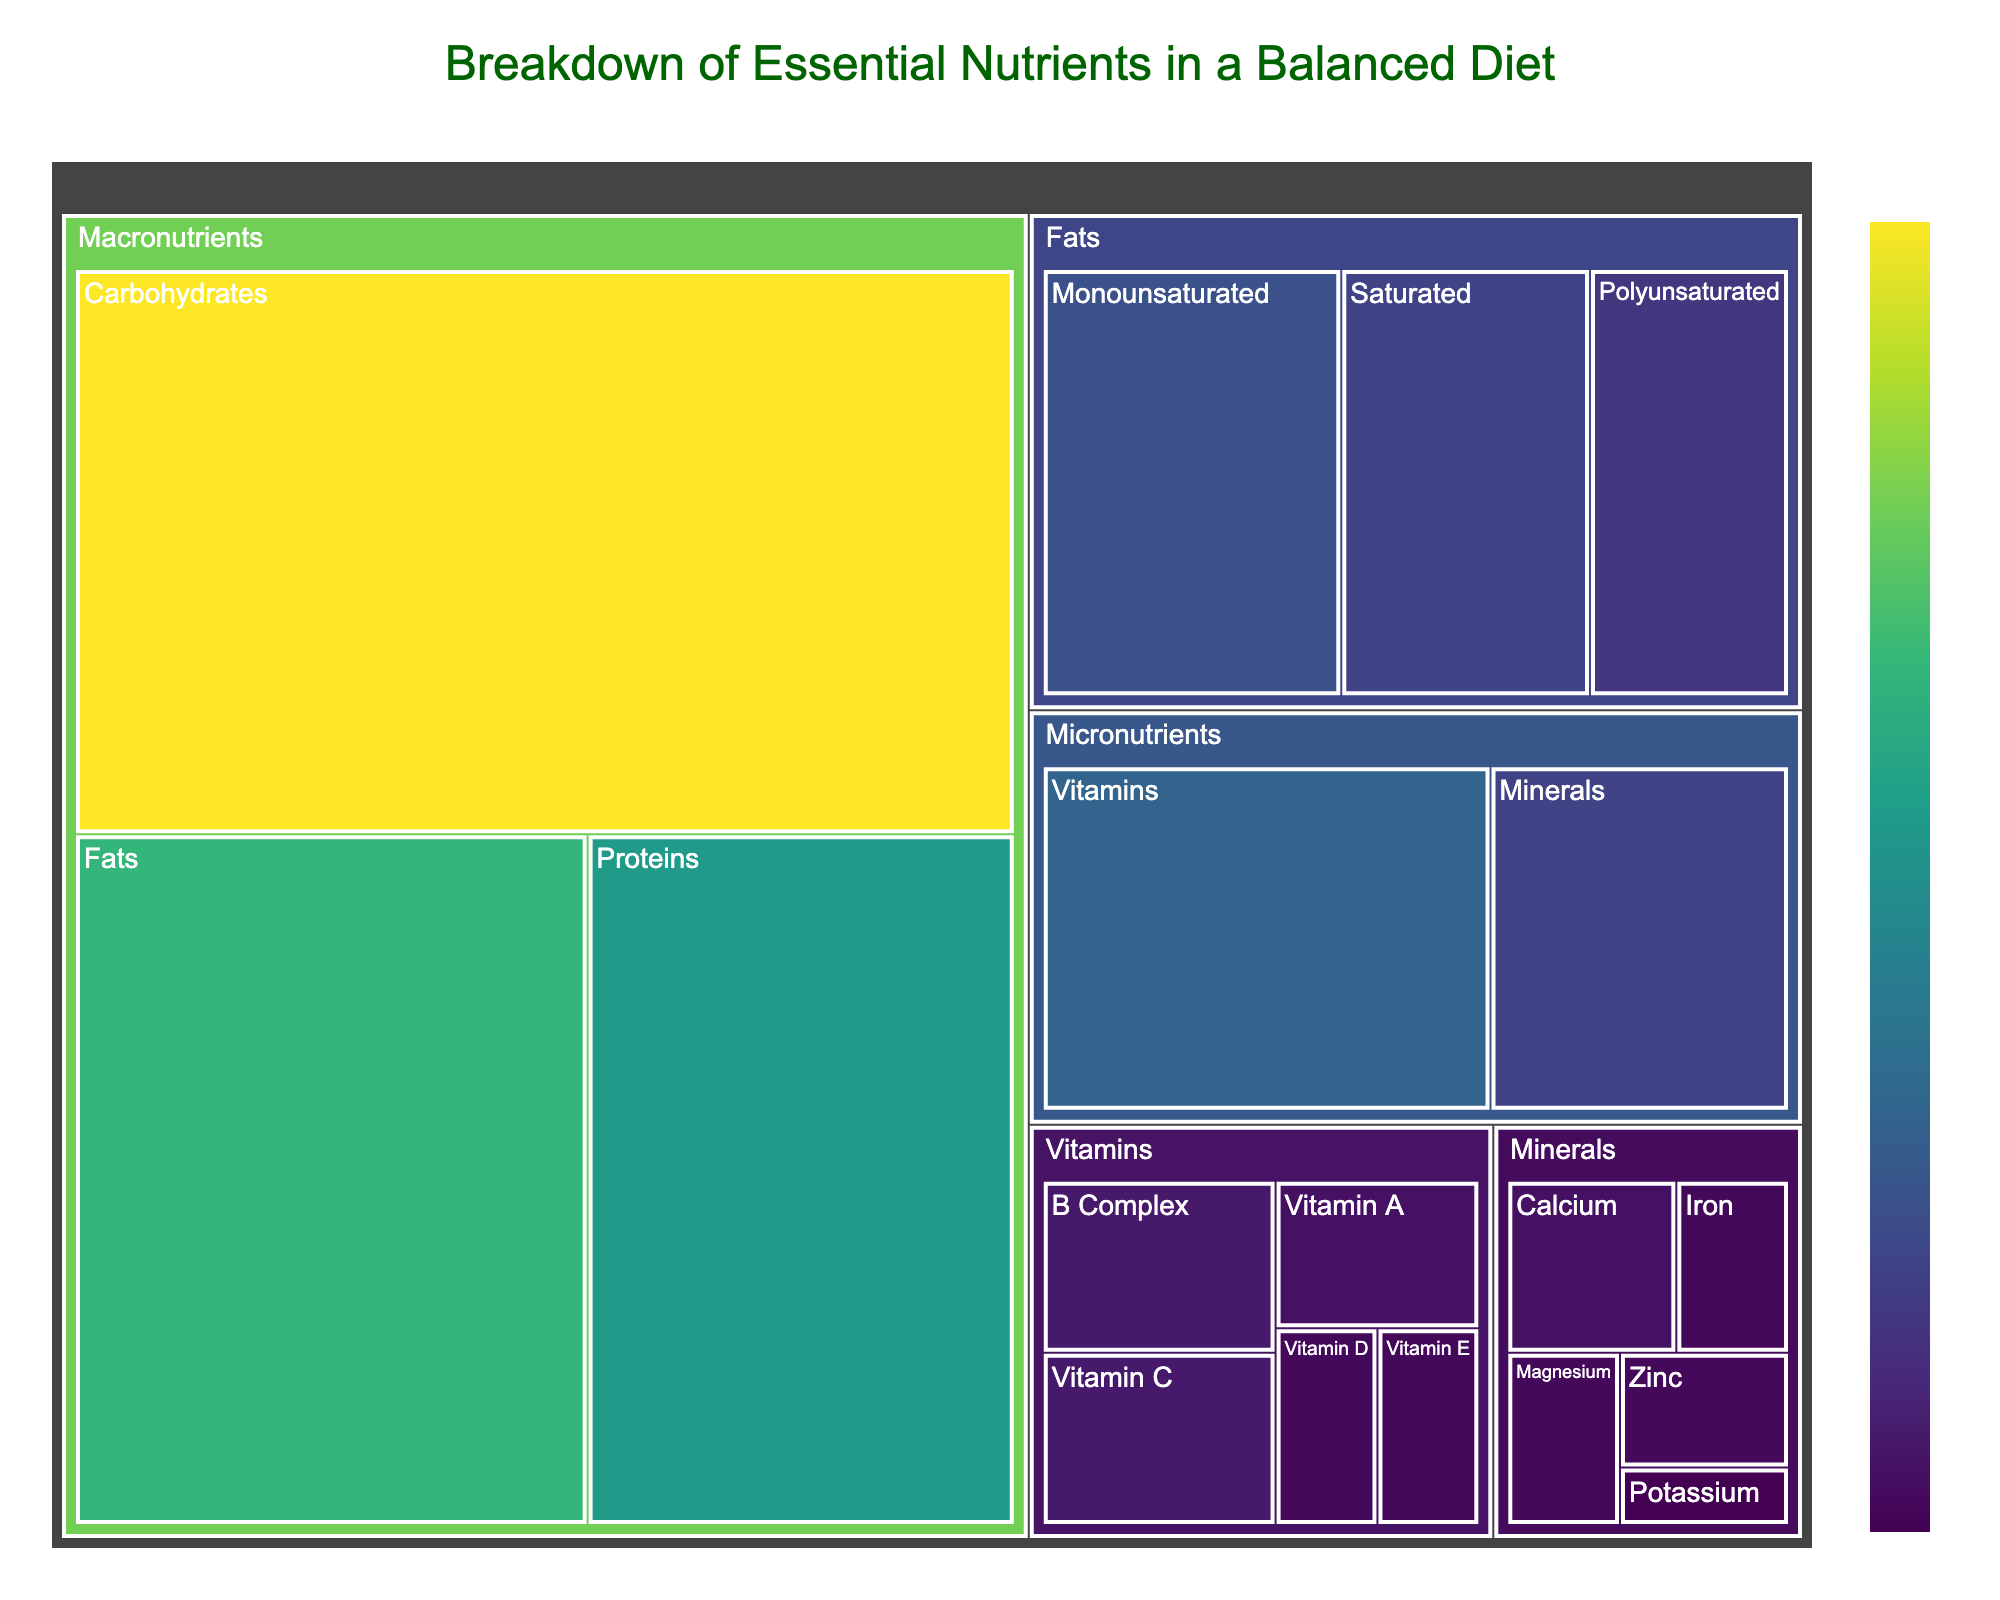What's the title of the treemap? The title of the treemap is usually located at the top of the chart and is written prominently.
Answer: Breakdown of Essential Nutrients in a Balanced Diet Which category contains the highest percentage value? By looking at the largest area in the treemap, the category with the highest value can be identified.
Answer: Macronutrients How many subcategories are present under the category 'Vitamins'? The treemap shows separate segments for each subcategory of 'Vitamins,' adding them up will give the number.
Answer: 5 What percentage of the total value is contributed by 'Proteins'? Locate the 'Proteins' segment within the 'Macronutrients' category and refer to the displayed percentage or value.
Answer: 25% What are the values for 'Monounsaturated' and 'Polyunsaturated' fats, and what is their combined total? Identify 'Monounsaturated' and 'Polyunsaturated' within the 'Fats' category, note their values, and sum them up.
Answer: Monounsaturated: 12, Polyunsaturated: 8, Combined total: 20 Which micronutrient has the lowest value and what is it? Look through each subcategory under 'Micronutrients' and identify the one with the smallest segment and its value.
Answer: Potassium, 1% How does the value of 'Saturated' fats compare to 'Polyunsaturated' fats? Find and compare the values of 'Saturated' and 'Polyunsaturated' fats within the 'Fats' segment.
Answer: Saturated (10) is greater than Polyunsaturated (8) What is the sum value of 'Vitamins' and 'Minerals'? Locate the segments for 'Vitamins' and 'Minerals' under 'Micronutrients' and add their values.
Answer: 15 (Vitamins) + 10 (Minerals) = 25 Under which main category would you find 'B Complex'? Identify the parent category to which 'B Complex' belongs by tracing its path in the treemap.
Answer: Vitamins If you combined the values of 'Calcium' and 'Vitamin C,' what percentage of the total value would they represent? Sum the values of 'Calcium' (3) and 'Vitamin C' (4), and then calculate their percentage of the total which can be derived by adding all values (100%).
Answer: 3 + 4 = 7, 7% of the total value 